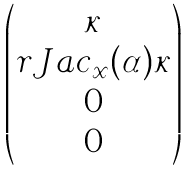<formula> <loc_0><loc_0><loc_500><loc_500>\begin{pmatrix} \kappa \\ r J a c _ { x } ( \alpha ) \kappa \\ 0 \\ 0 \end{pmatrix}</formula> 